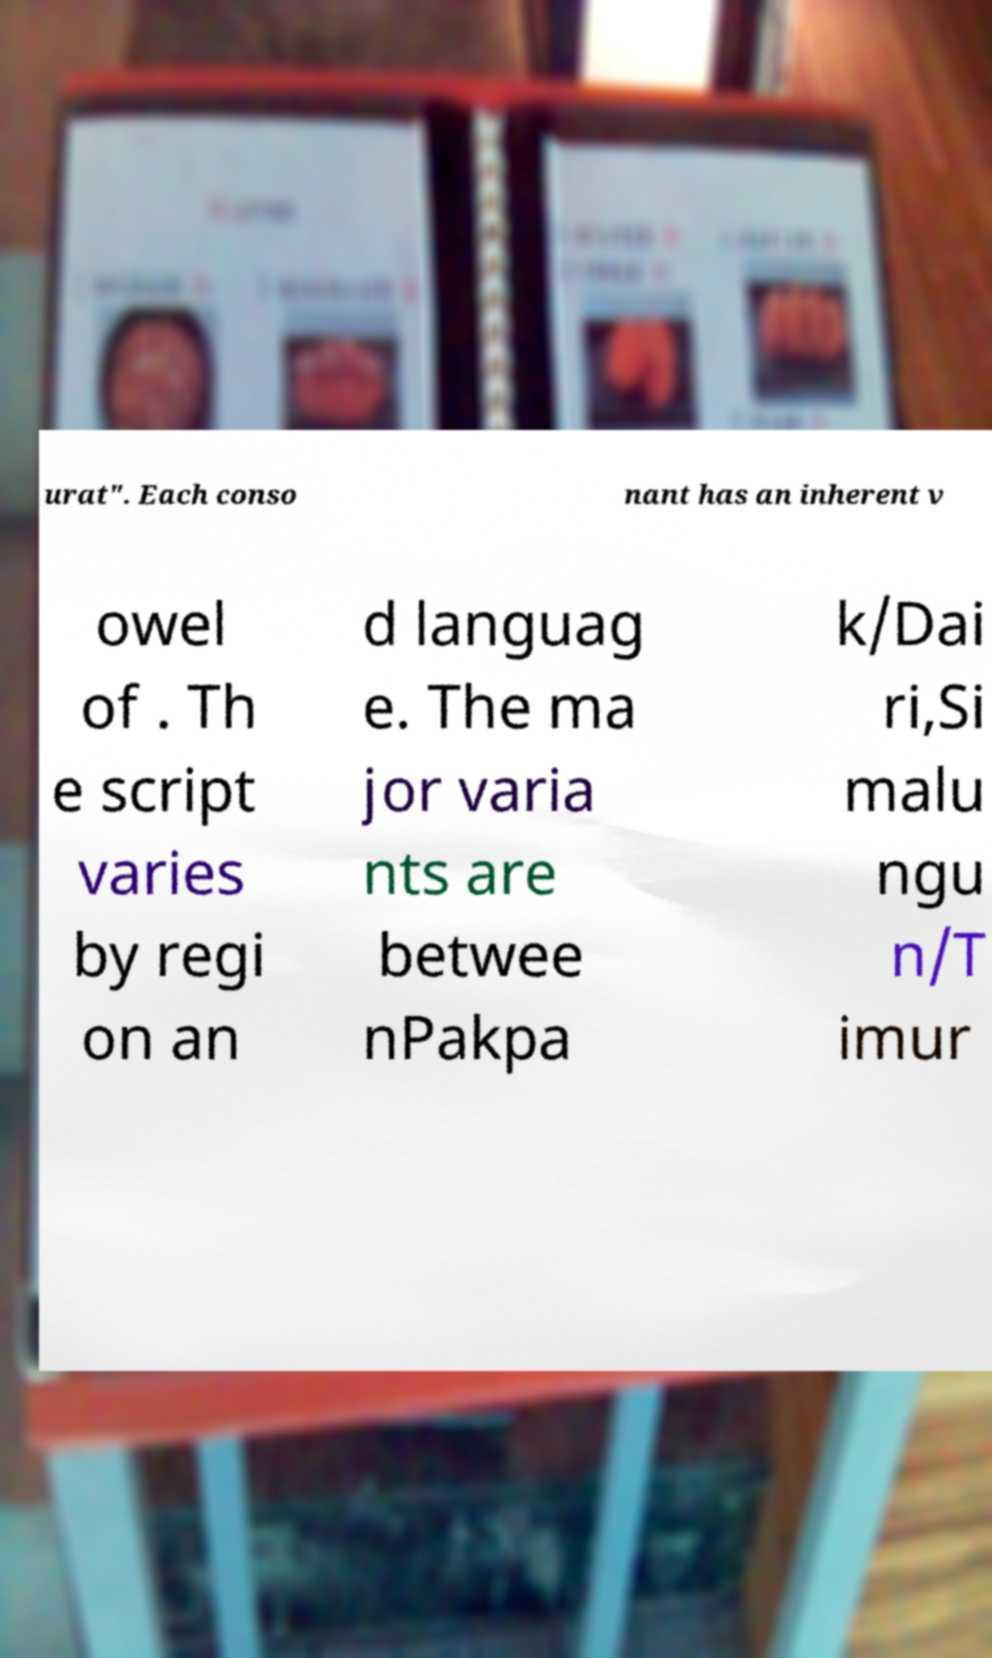Can you accurately transcribe the text from the provided image for me? urat". Each conso nant has an inherent v owel of . Th e script varies by regi on an d languag e. The ma jor varia nts are betwee nPakpa k/Dai ri,Si malu ngu n/T imur 